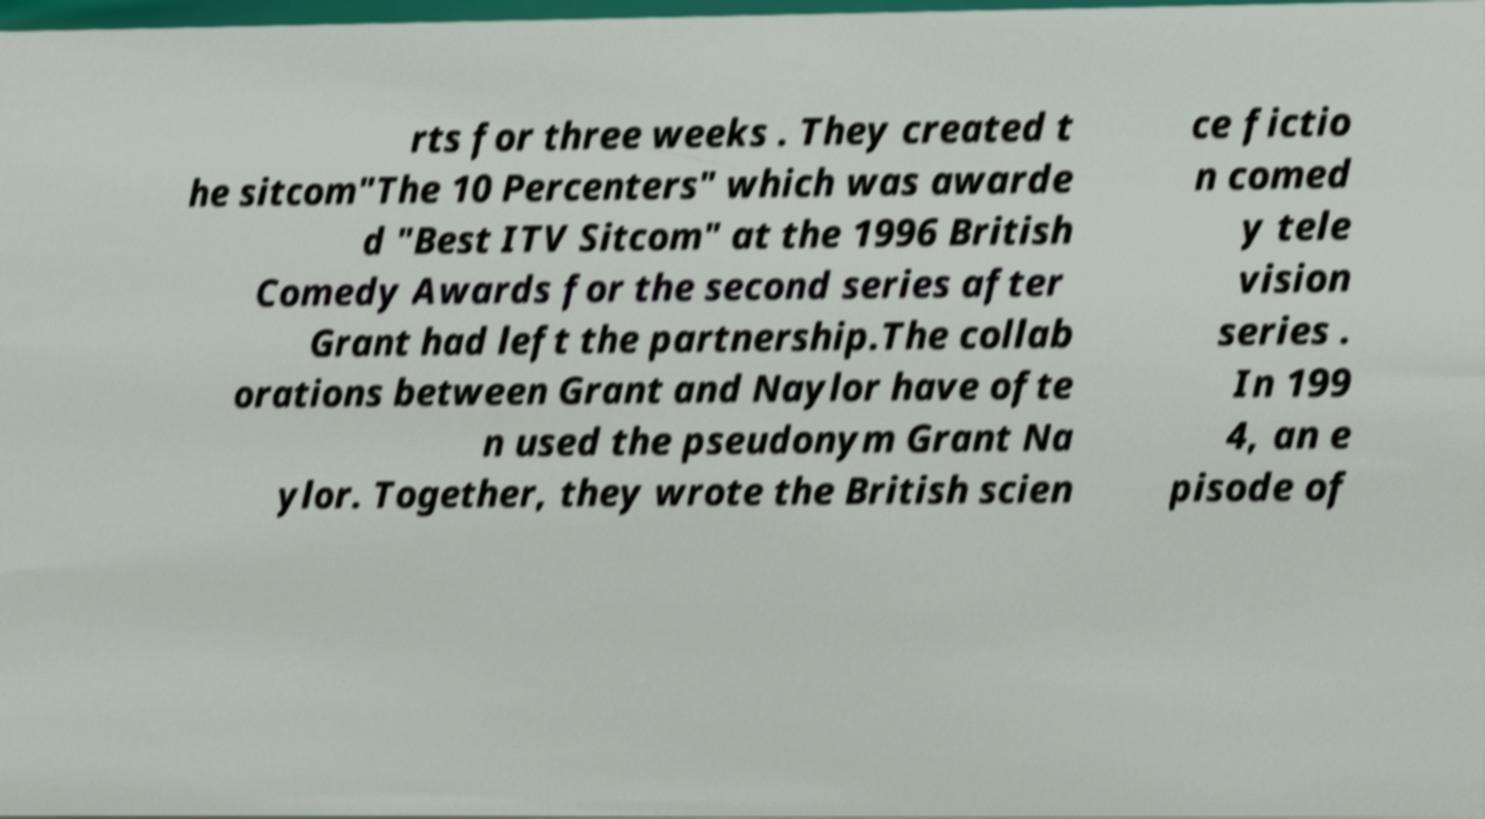Please read and relay the text visible in this image. What does it say? rts for three weeks . They created t he sitcom"The 10 Percenters" which was awarde d "Best ITV Sitcom" at the 1996 British Comedy Awards for the second series after Grant had left the partnership.The collab orations between Grant and Naylor have ofte n used the pseudonym Grant Na ylor. Together, they wrote the British scien ce fictio n comed y tele vision series . In 199 4, an e pisode of 